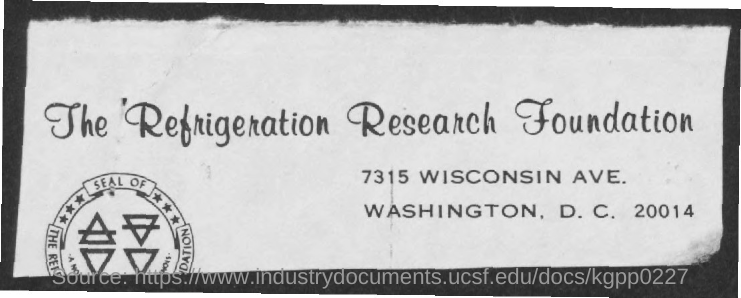What is the name of the foundation mentioned ?
Offer a terse response. The refrigeration research foundation. 